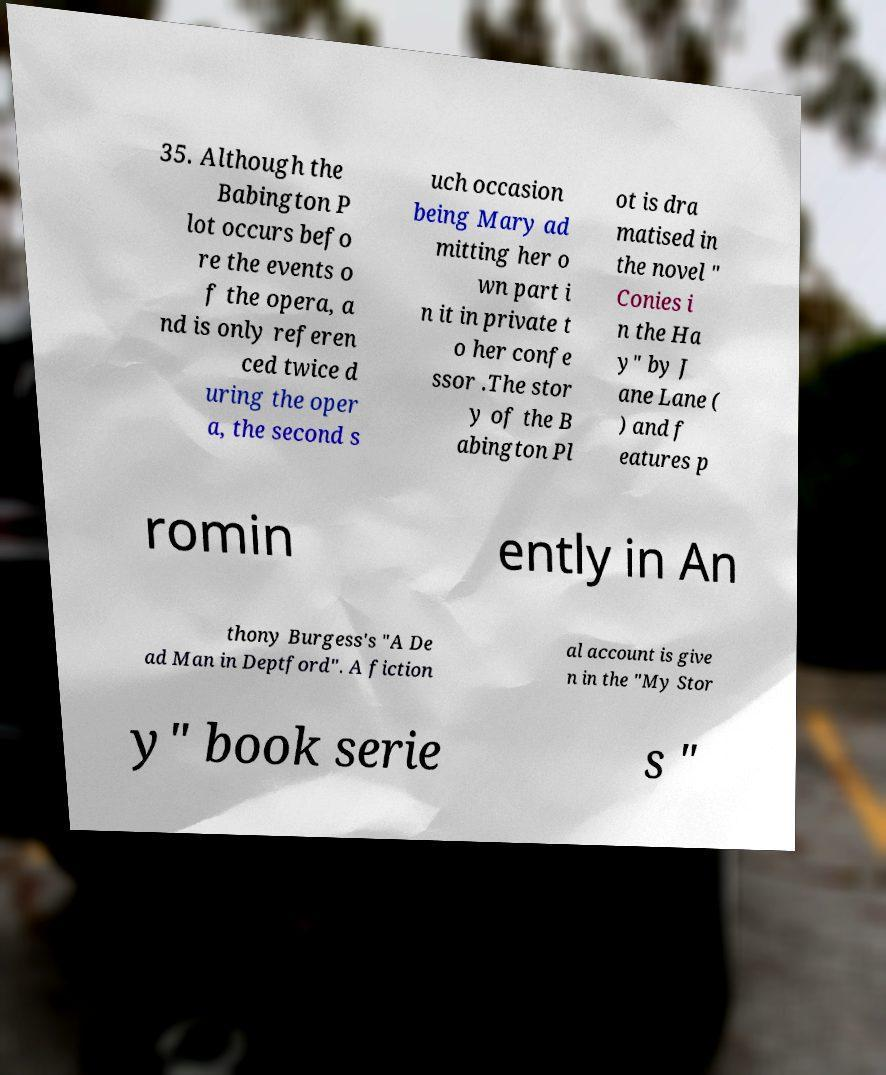Can you read and provide the text displayed in the image?This photo seems to have some interesting text. Can you extract and type it out for me? 35. Although the Babington P lot occurs befo re the events o f the opera, a nd is only referen ced twice d uring the oper a, the second s uch occasion being Mary ad mitting her o wn part i n it in private t o her confe ssor .The stor y of the B abington Pl ot is dra matised in the novel " Conies i n the Ha y" by J ane Lane ( ) and f eatures p romin ently in An thony Burgess's "A De ad Man in Deptford". A fiction al account is give n in the "My Stor y" book serie s " 